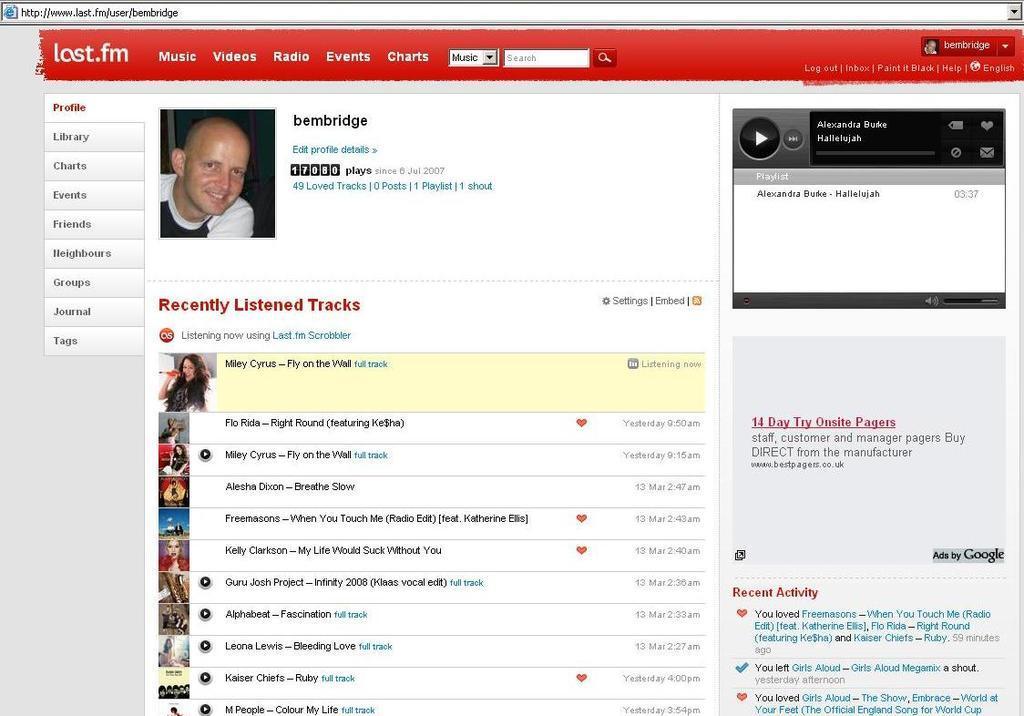Please provide a concise description of this image. In this picture we can see a web page, we can see a person´s image here, there are some tags here, we can see a digital audio player on the right side, there is some text here. 